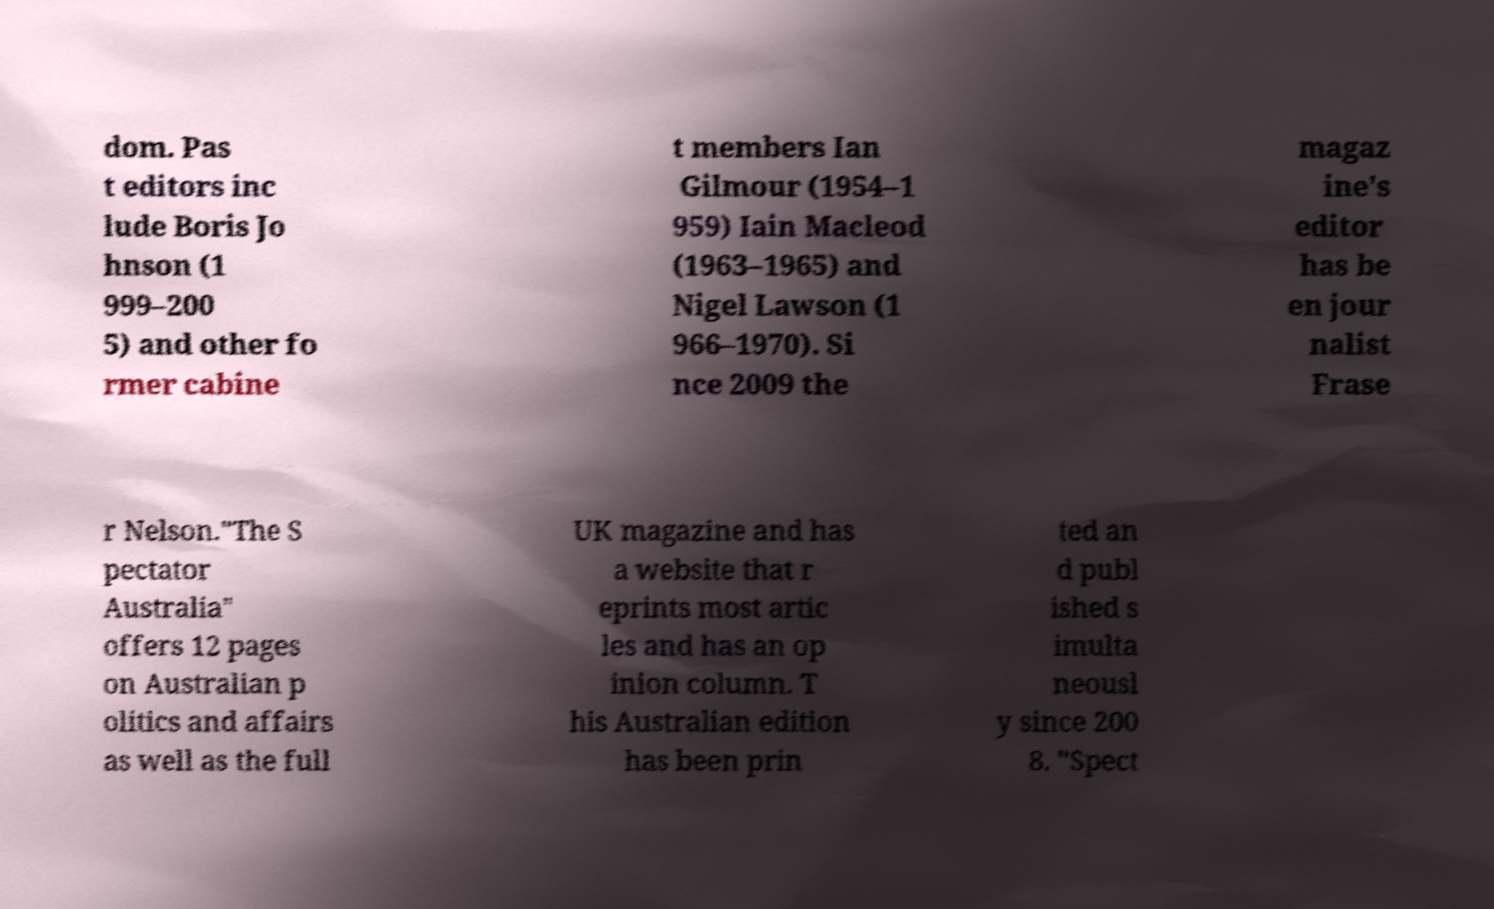Can you read and provide the text displayed in the image?This photo seems to have some interesting text. Can you extract and type it out for me? dom. Pas t editors inc lude Boris Jo hnson (1 999–200 5) and other fo rmer cabine t members Ian Gilmour (1954–1 959) Iain Macleod (1963–1965) and Nigel Lawson (1 966–1970). Si nce 2009 the magaz ine's editor has be en jour nalist Frase r Nelson."The S pectator Australia" offers 12 pages on Australian p olitics and affairs as well as the full UK magazine and has a website that r eprints most artic les and has an op inion column. T his Australian edition has been prin ted an d publ ished s imulta neousl y since 200 8. "Spect 